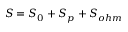<formula> <loc_0><loc_0><loc_500><loc_500>S = S _ { 0 } + S _ { p } + S _ { o h m }</formula> 